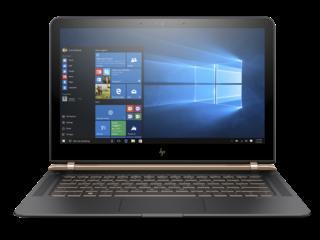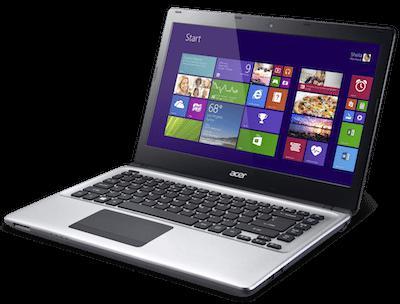The first image is the image on the left, the second image is the image on the right. Given the left and right images, does the statement "The lids of all laptop computers are fully upright." hold true? Answer yes or no. Yes. The first image is the image on the left, the second image is the image on the right. For the images shown, is this caption "The laptop in the image on the left is facing forward." true? Answer yes or no. Yes. 